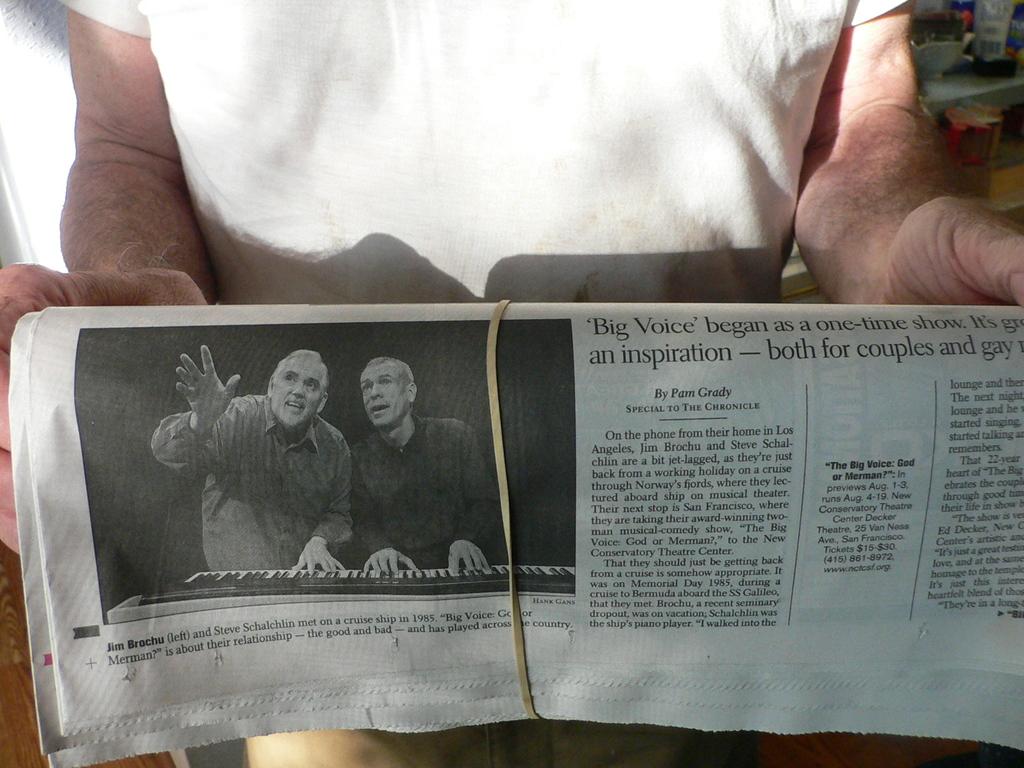Who is the person on the left of the picture?
Your answer should be compact. Jim brochu. 